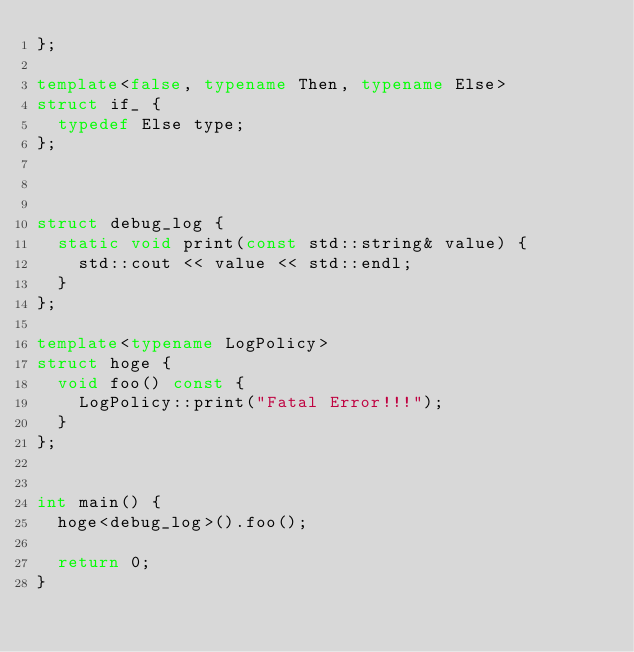Convert code to text. <code><loc_0><loc_0><loc_500><loc_500><_C++_>};

template<false, typename Then, typename Else>
struct if_ {
	typedef Else type;
};



struct debug_log {
	static void print(const std::string& value) {
		std::cout << value << std::endl;
	}
};

template<typename LogPolicy>
struct hoge {
	void foo() const {
		LogPolicy::print("Fatal Error!!!");
	}
};


int main() {
	hoge<debug_log>().foo();

	return 0;
}

</code> 